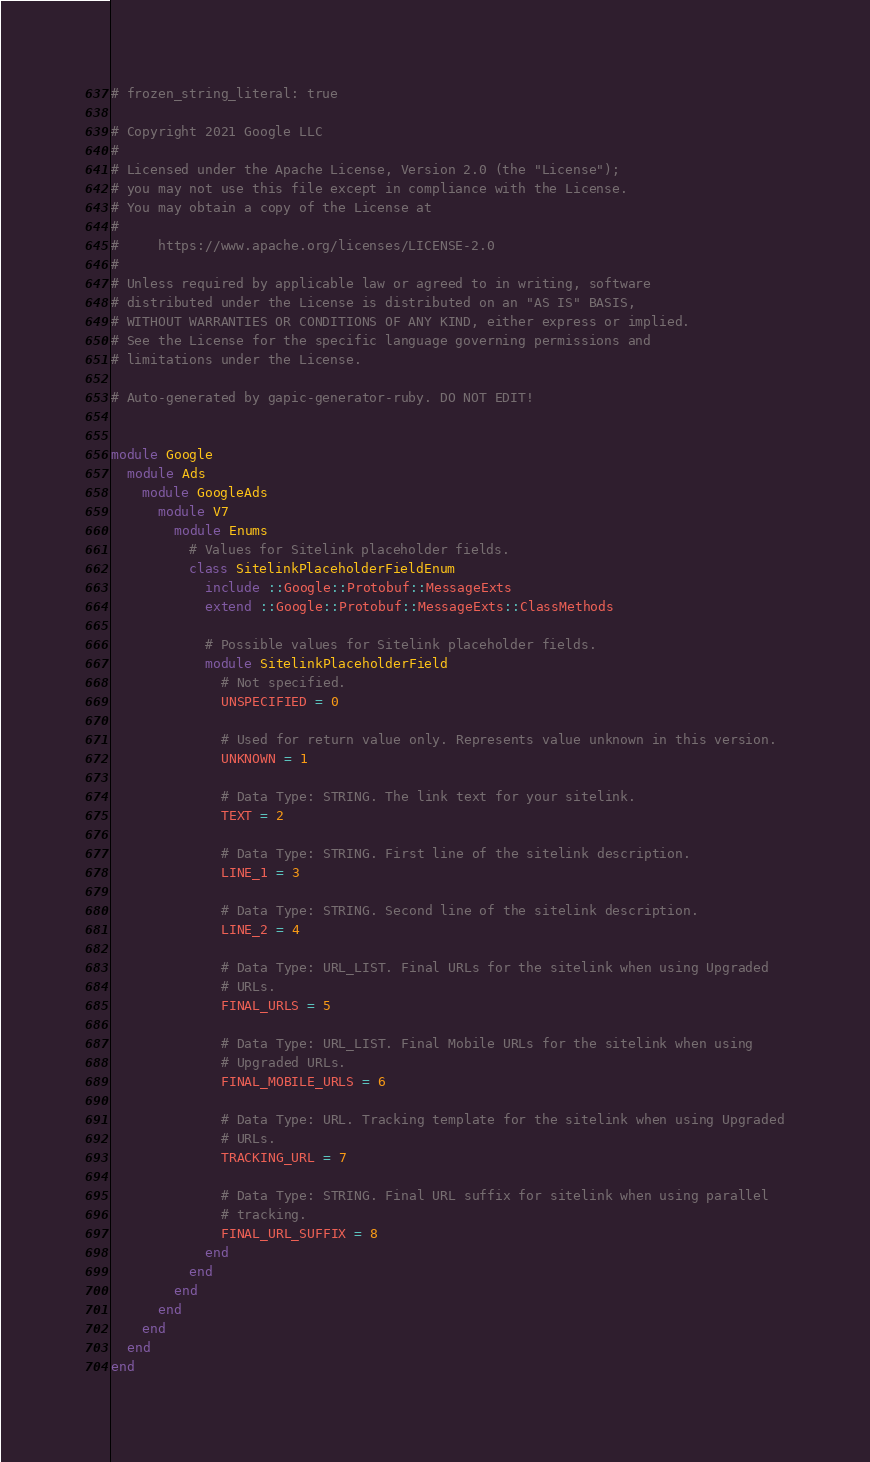<code> <loc_0><loc_0><loc_500><loc_500><_Ruby_># frozen_string_literal: true

# Copyright 2021 Google LLC
#
# Licensed under the Apache License, Version 2.0 (the "License");
# you may not use this file except in compliance with the License.
# You may obtain a copy of the License at
#
#     https://www.apache.org/licenses/LICENSE-2.0
#
# Unless required by applicable law or agreed to in writing, software
# distributed under the License is distributed on an "AS IS" BASIS,
# WITHOUT WARRANTIES OR CONDITIONS OF ANY KIND, either express or implied.
# See the License for the specific language governing permissions and
# limitations under the License.

# Auto-generated by gapic-generator-ruby. DO NOT EDIT!


module Google
  module Ads
    module GoogleAds
      module V7
        module Enums
          # Values for Sitelink placeholder fields.
          class SitelinkPlaceholderFieldEnum
            include ::Google::Protobuf::MessageExts
            extend ::Google::Protobuf::MessageExts::ClassMethods

            # Possible values for Sitelink placeholder fields.
            module SitelinkPlaceholderField
              # Not specified.
              UNSPECIFIED = 0

              # Used for return value only. Represents value unknown in this version.
              UNKNOWN = 1

              # Data Type: STRING. The link text for your sitelink.
              TEXT = 2

              # Data Type: STRING. First line of the sitelink description.
              LINE_1 = 3

              # Data Type: STRING. Second line of the sitelink description.
              LINE_2 = 4

              # Data Type: URL_LIST. Final URLs for the sitelink when using Upgraded
              # URLs.
              FINAL_URLS = 5

              # Data Type: URL_LIST. Final Mobile URLs for the sitelink when using
              # Upgraded URLs.
              FINAL_MOBILE_URLS = 6

              # Data Type: URL. Tracking template for the sitelink when using Upgraded
              # URLs.
              TRACKING_URL = 7

              # Data Type: STRING. Final URL suffix for sitelink when using parallel
              # tracking.
              FINAL_URL_SUFFIX = 8
            end
          end
        end
      end
    end
  end
end
</code> 